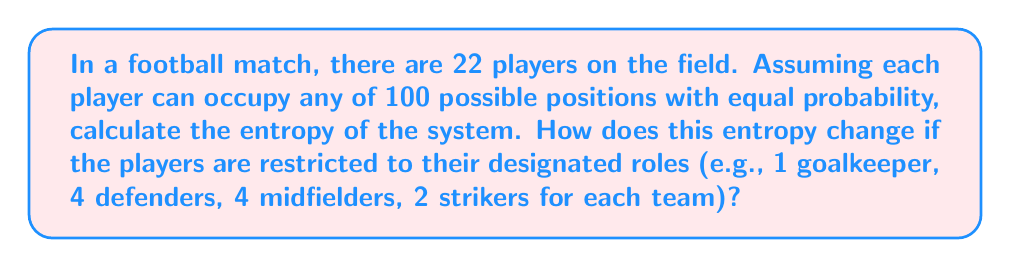Give your solution to this math problem. Let's approach this problem step-by-step:

1) First, let's calculate the entropy when players can occupy any position:

   The number of possible microstates is $100^{22}$, as each of the 22 players can be in any of 100 positions.

   The probability of any specific microstate is $p = \frac{1}{100^{22}}$.

   The entropy is given by Boltzmann's formula:
   
   $$S = k_B \ln W$$

   Where $W$ is the number of microstates and $k_B$ is Boltzmann's constant.

   $$S = k_B \ln(100^{22}) = 22k_B \ln(100)$$

2) Now, let's calculate the entropy when players are restricted to their roles:

   For each team:
   - 1 goalkeeper: 1 position
   - 4 defenders: 4 positions each
   - 4 midfielders: 4 positions each
   - 2 strikers: 2 positions each

   The number of microstates is:
   
   $$W = (1 \cdot 4^4 \cdot 4^4 \cdot 2^2)^2$$

   The entropy in this case is:

   $$S_{restricted} = k_B \ln((1 \cdot 4^4 \cdot 4^4 \cdot 2^2)^2)$$
   
   $$= 2k_B \ln(1 \cdot 4^4 \cdot 4^4 \cdot 2^2)$$
   
   $$= 2k_B \ln(2^{18} \cdot 4^8)$$
   
   $$= 2k_B (18\ln(2) + 8\ln(4))$$
   
   $$= 2k_B (18\ln(2) + 16\ln(2))$$
   
   $$= 68k_B \ln(2)$$

3) The change in entropy is:

   $$\Delta S = S - S_{restricted}$$
   
   $$= 22k_B \ln(100) - 68k_B \ln(2)$$
   
   $$= 22k_B (4.6052) - 68k_B (0.6931)$$
   
   $$= 101.3144k_B - 47.1308k_B$$
   
   $$= 54.1836k_B$$
Answer: $54.1836k_B$ 